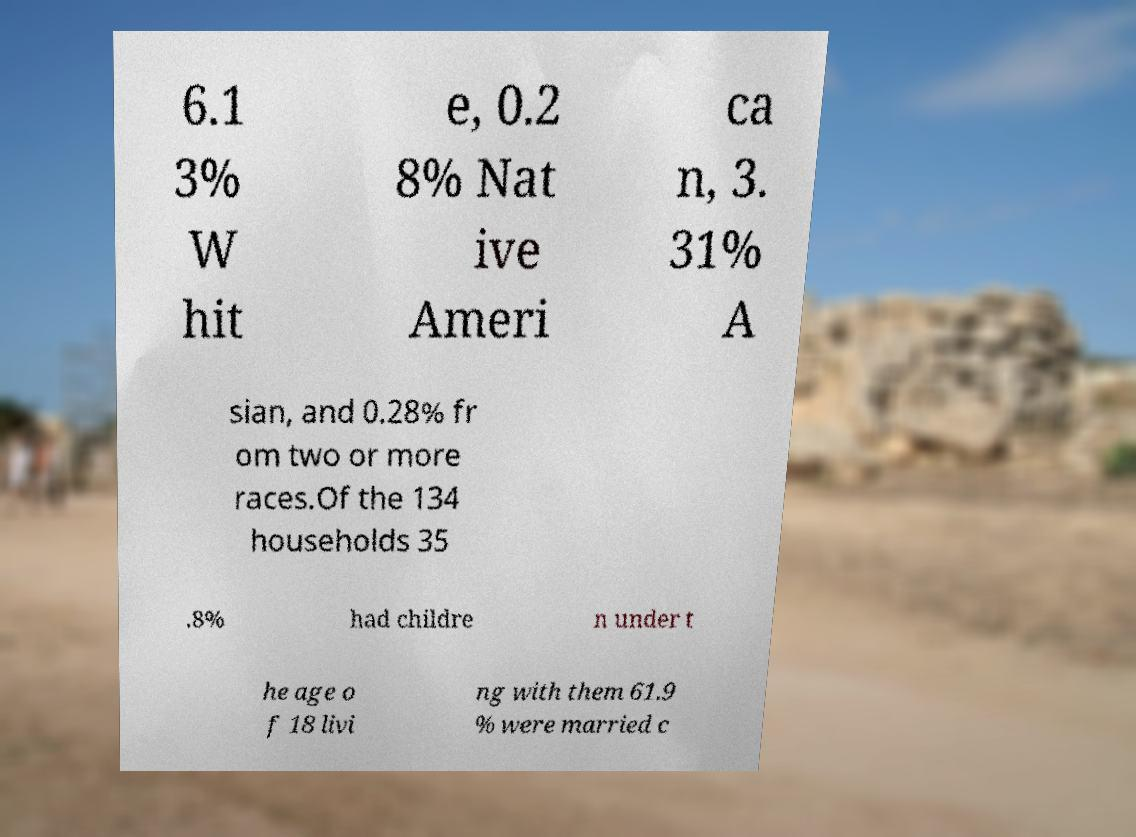Can you accurately transcribe the text from the provided image for me? 6.1 3% W hit e, 0.2 8% Nat ive Ameri ca n, 3. 31% A sian, and 0.28% fr om two or more races.Of the 134 households 35 .8% had childre n under t he age o f 18 livi ng with them 61.9 % were married c 